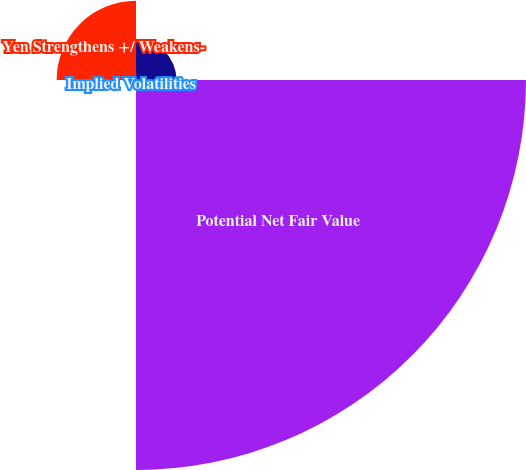<chart> <loc_0><loc_0><loc_500><loc_500><pie_chart><fcel>Equity Market Return<fcel>Potential Net Fair Value<fcel>Implied Volatilities<fcel>Yen Strengthens +/ Weakens-<nl><fcel>7.92%<fcel>76.23%<fcel>0.33%<fcel>15.51%<nl></chart> 